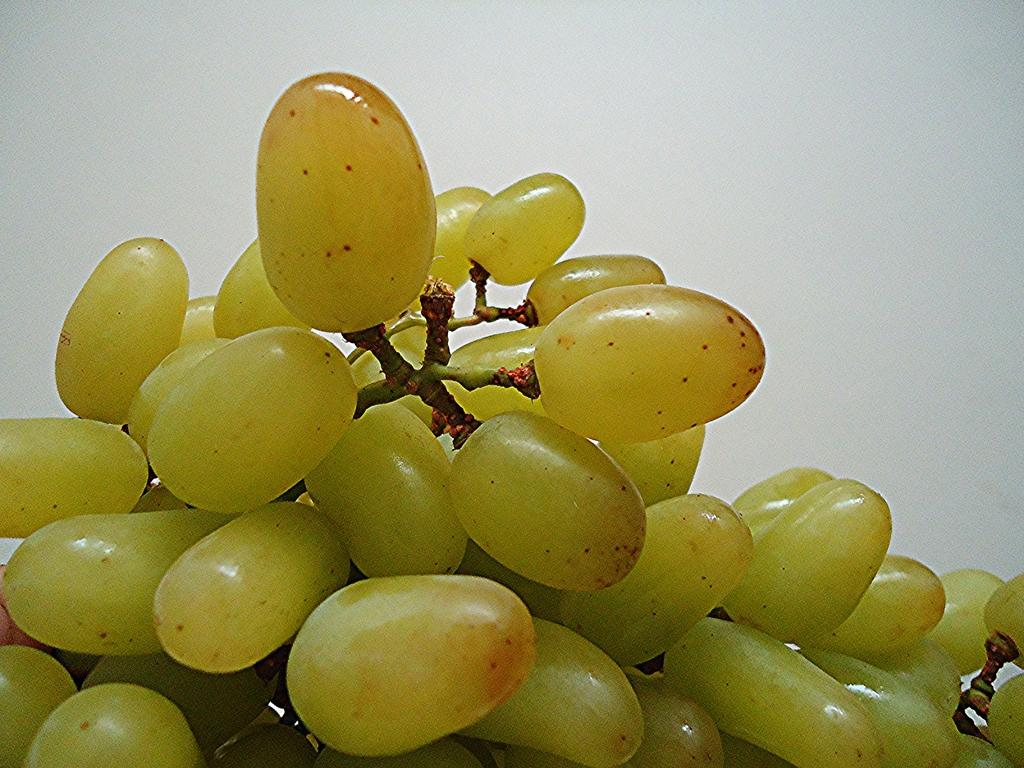What type of fruit is visible in the image? There are green color grapes in the image. Can you describe the color of the grapes? The grapes are green in color. How many boats are visible in the image? There are no boats present in the image; it features green color grapes. What stage of development are the grapes in the image? The image does not provide information about the stage of development of the grapes. 